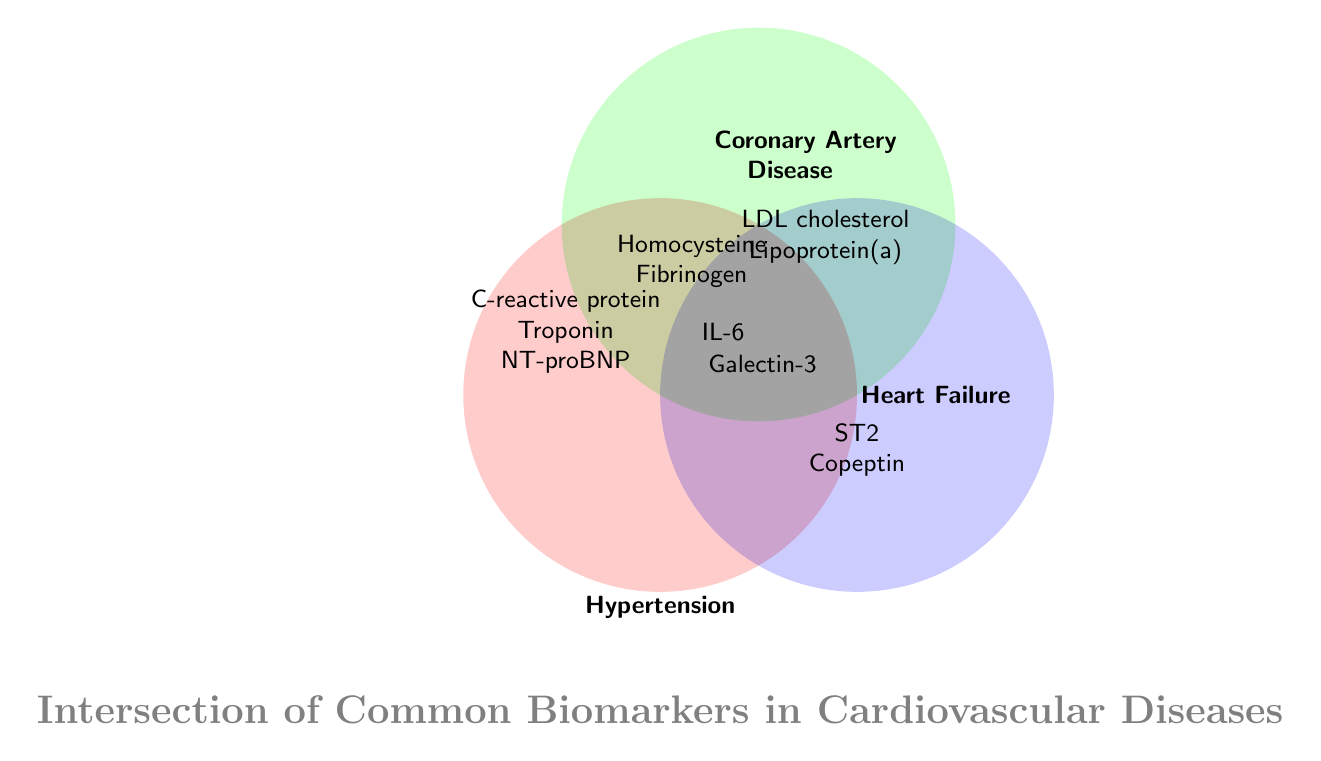Which biomarker is common to Hypertension, Coronary Artery Disease, and Heart Failure? IL-6 is located at the intersection of all three circles representing Hypertension, Coronary Artery Disease, and Heart Failure. This indicates it is common to all three conditions.
Answer: IL-6 How many biomarkers are specific only to Hypertension? In the Hypertension circle, the biomarkers that do not overlap with any other circle are C-reactive protein, Troponin, and NT-proBNP.
Answer: 3 List the biomarkers that are shared between Hypertension and Coronary Artery Disease but not Heart Failure. The overlap area between Hypertension and Coronary Artery Disease that does not intersect with Heart Failure contains Homocysteine and Fibrinogen.
Answer: Homocysteine, Fibrinogen Which disease has the highest number of biomarkers mentioned in the diagram? Counting the biomarkers specific only to each disease and those in the intersecting areas: Hypertension (5: C-reactive protein, Troponin, NT-proBNP, Homocysteine, Fibrinogen), Coronary Artery Disease (5: LDL cholesterol, Lipoprotein(a), Homocysteine, Fibrinogen, Galectin-3), Heart Failure (4: ST2, Copeptin, Galectin-3, IL-6). Hypertension and Coronary Artery Disease both have 5 biomarkers.
Answer: Hypertension, Coronary Artery Disease What biomarkers are specific to Heart Failure only? The biomarkers located solely in the Heart Failure circle without overlapping any other circles are ST2 and Copeptin.
Answer: ST2, Copeptin 